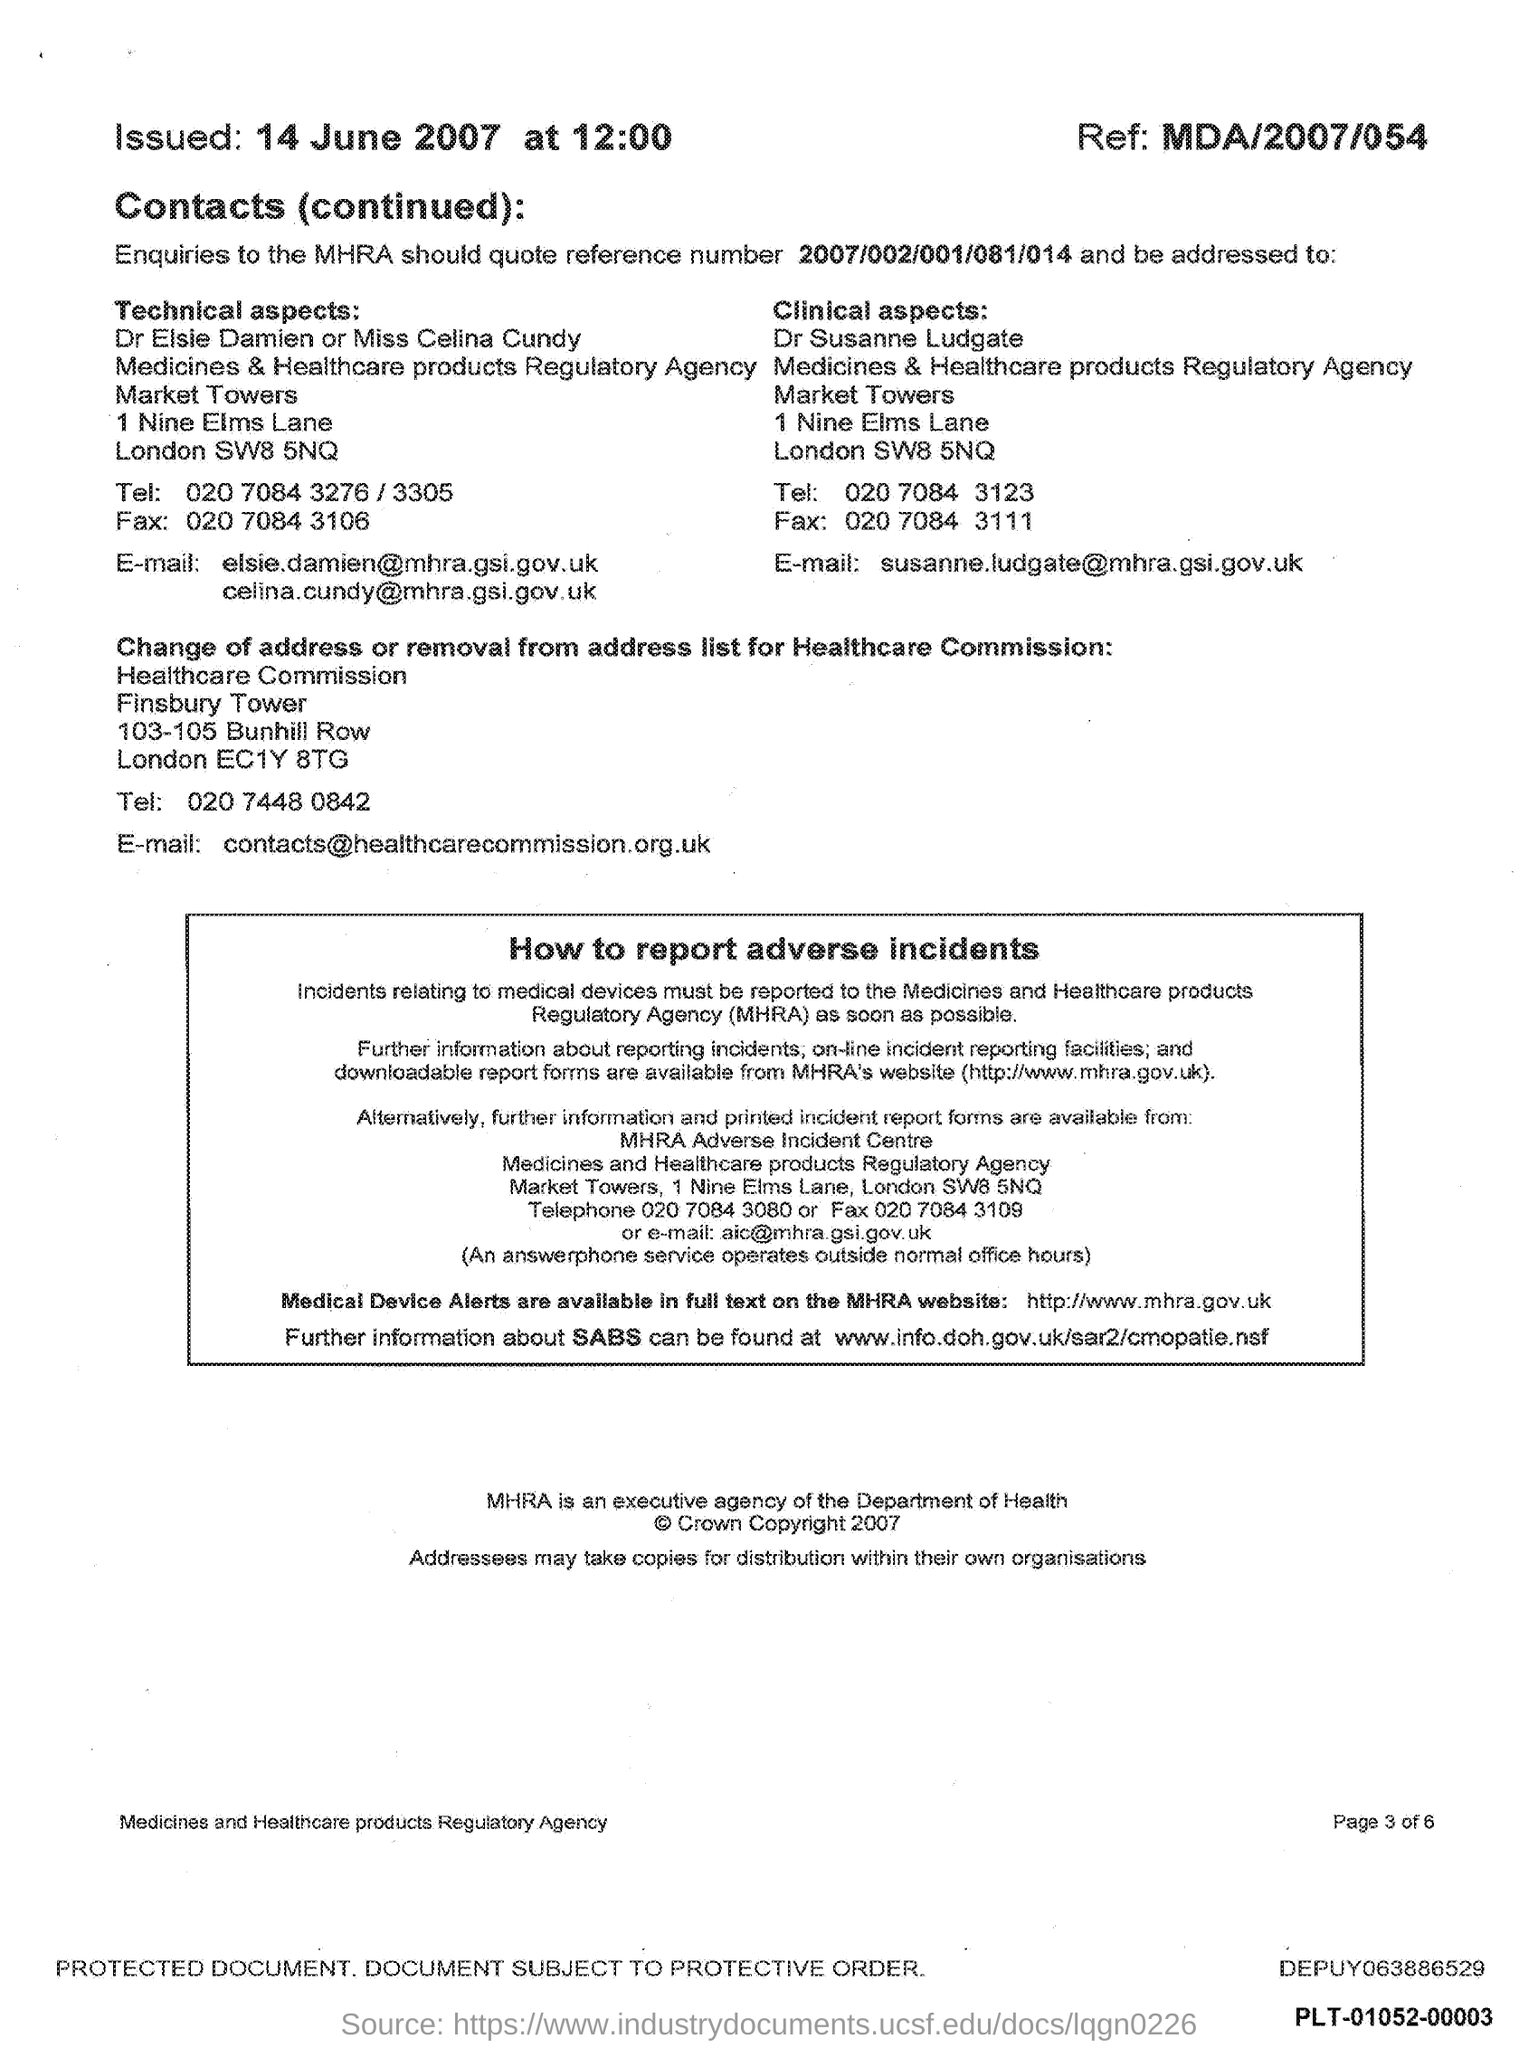What is the issued date mentioned in this document?
Provide a short and direct response. 14 june 2007. What is the issued time mentioned in this document?
Offer a very short reply. 12:00. What is the Ref # mentioned in this document?
Keep it short and to the point. MDA/2007/054. 